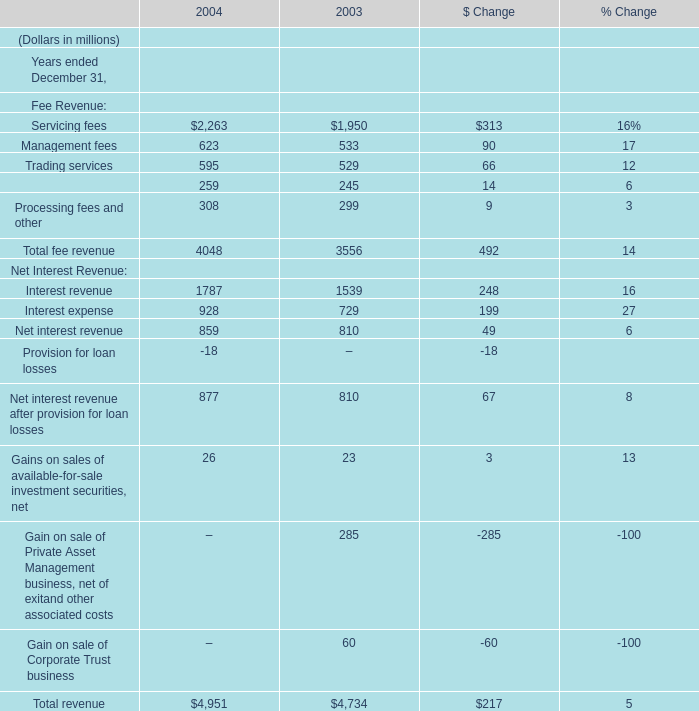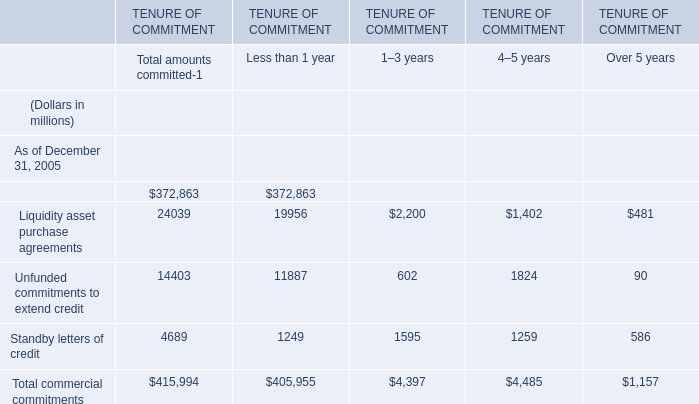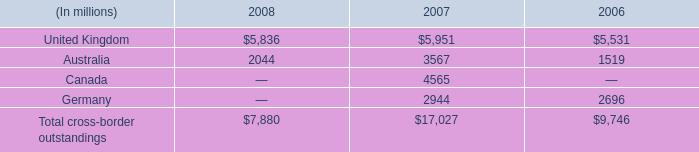What's the sum of Standby letters of credit of TENURE OF COMMITMENT 1–3 years, and Servicing fees of 2004 ? 
Computations: (1595.0 + 2263.0)
Answer: 3858.0. 